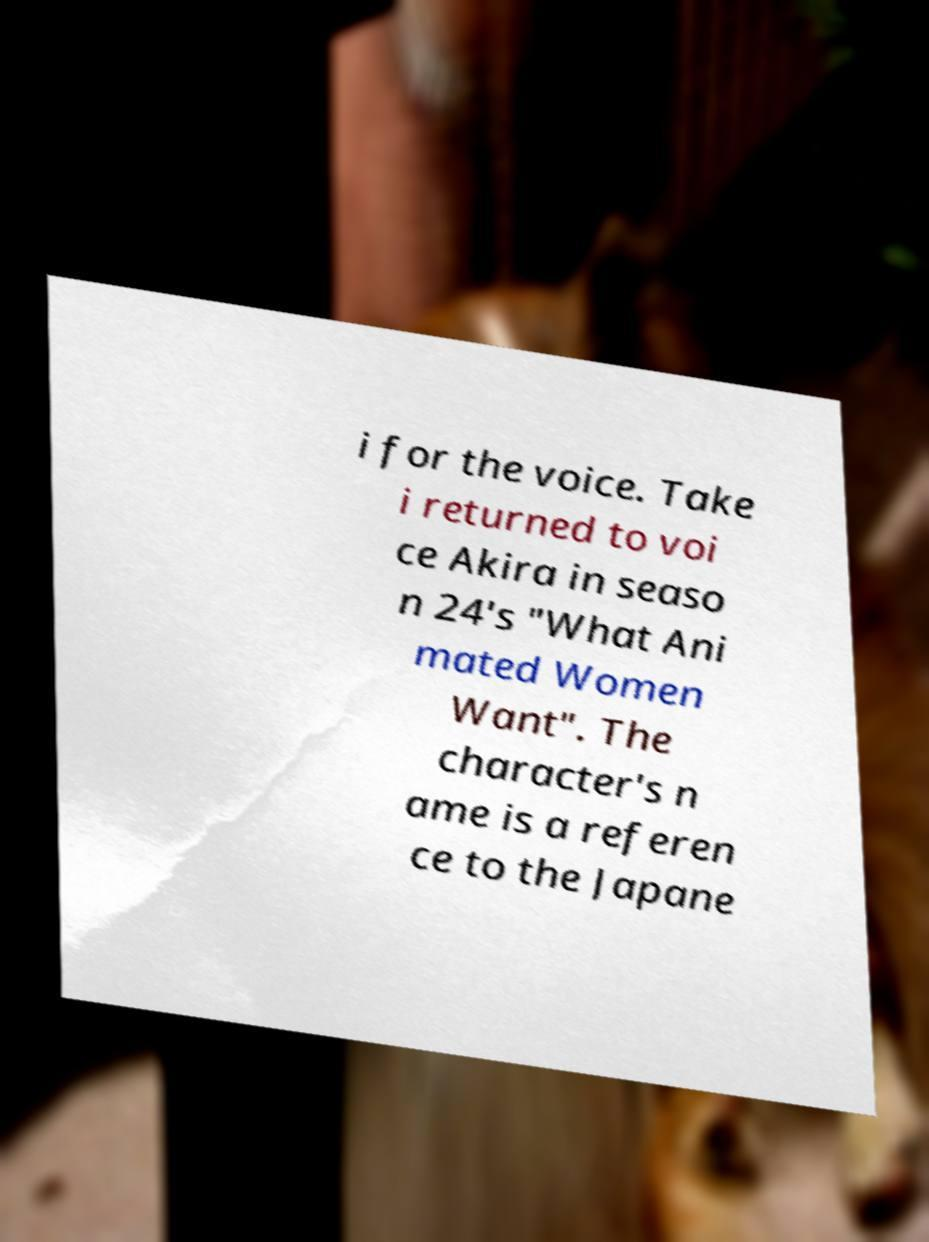Could you extract and type out the text from this image? i for the voice. Take i returned to voi ce Akira in seaso n 24's "What Ani mated Women Want". The character's n ame is a referen ce to the Japane 